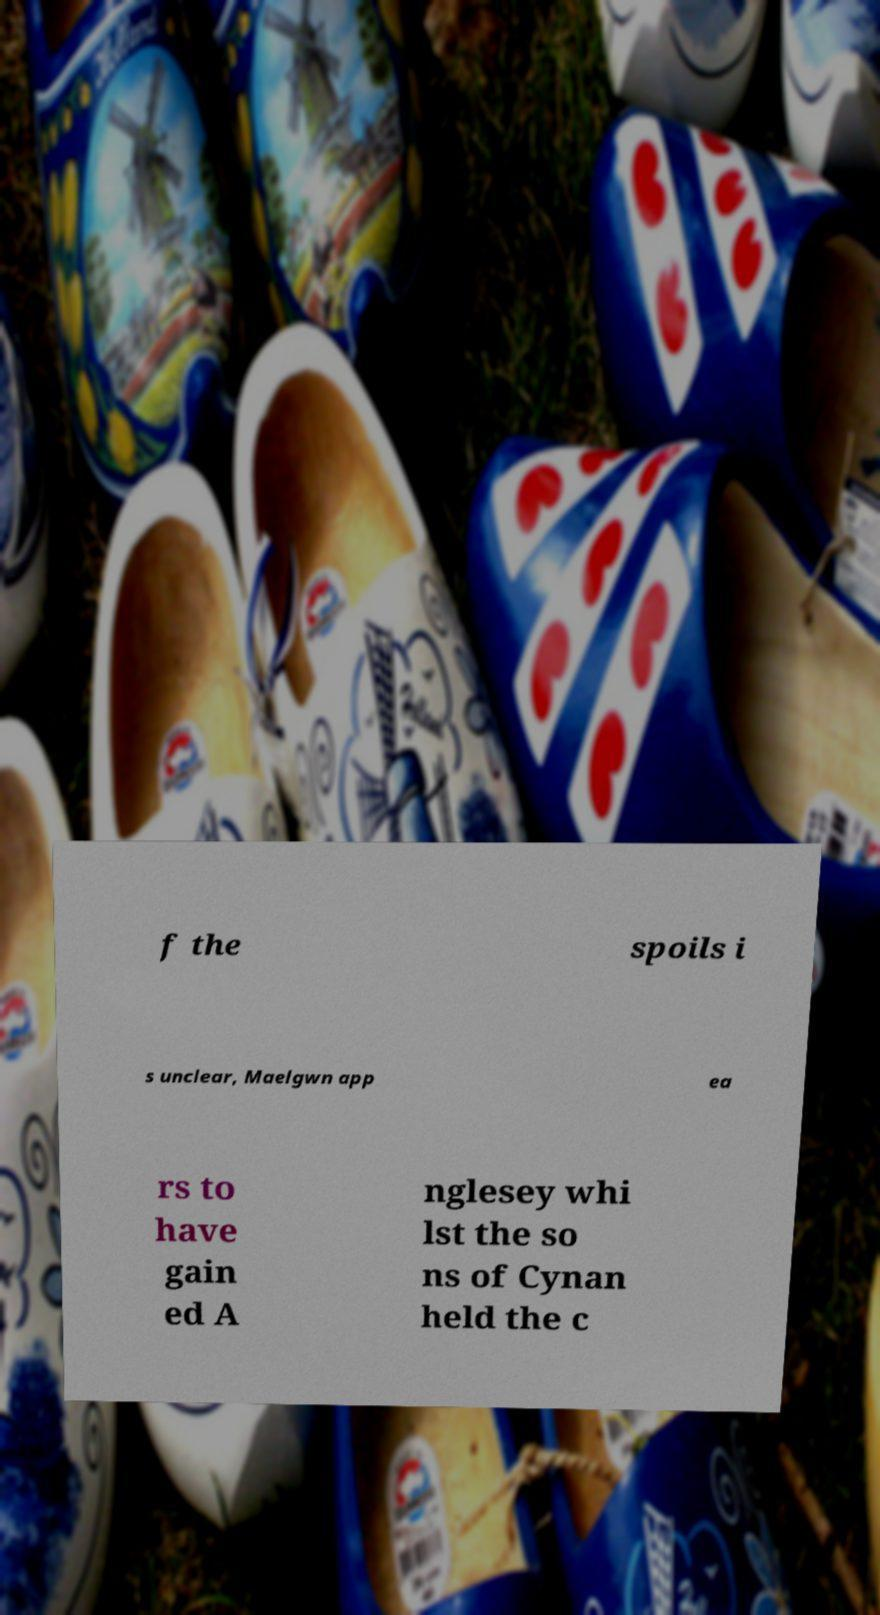Please identify and transcribe the text found in this image. f the spoils i s unclear, Maelgwn app ea rs to have gain ed A nglesey whi lst the so ns of Cynan held the c 